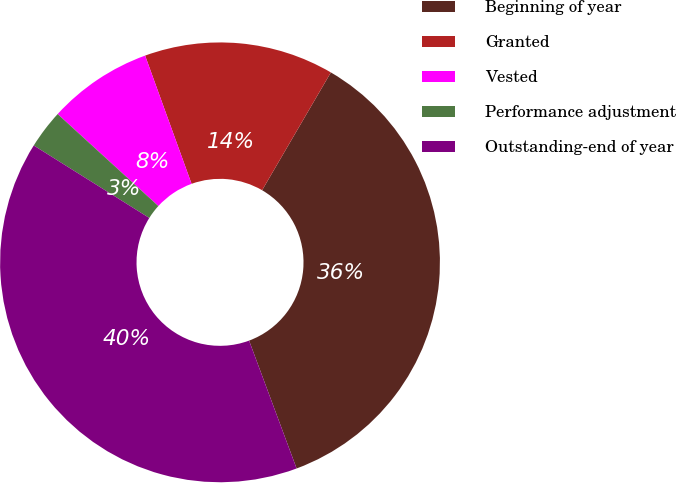Convert chart to OTSL. <chart><loc_0><loc_0><loc_500><loc_500><pie_chart><fcel>Beginning of year<fcel>Granted<fcel>Vested<fcel>Performance adjustment<fcel>Outstanding-end of year<nl><fcel>35.93%<fcel>13.94%<fcel>7.69%<fcel>2.86%<fcel>39.58%<nl></chart> 